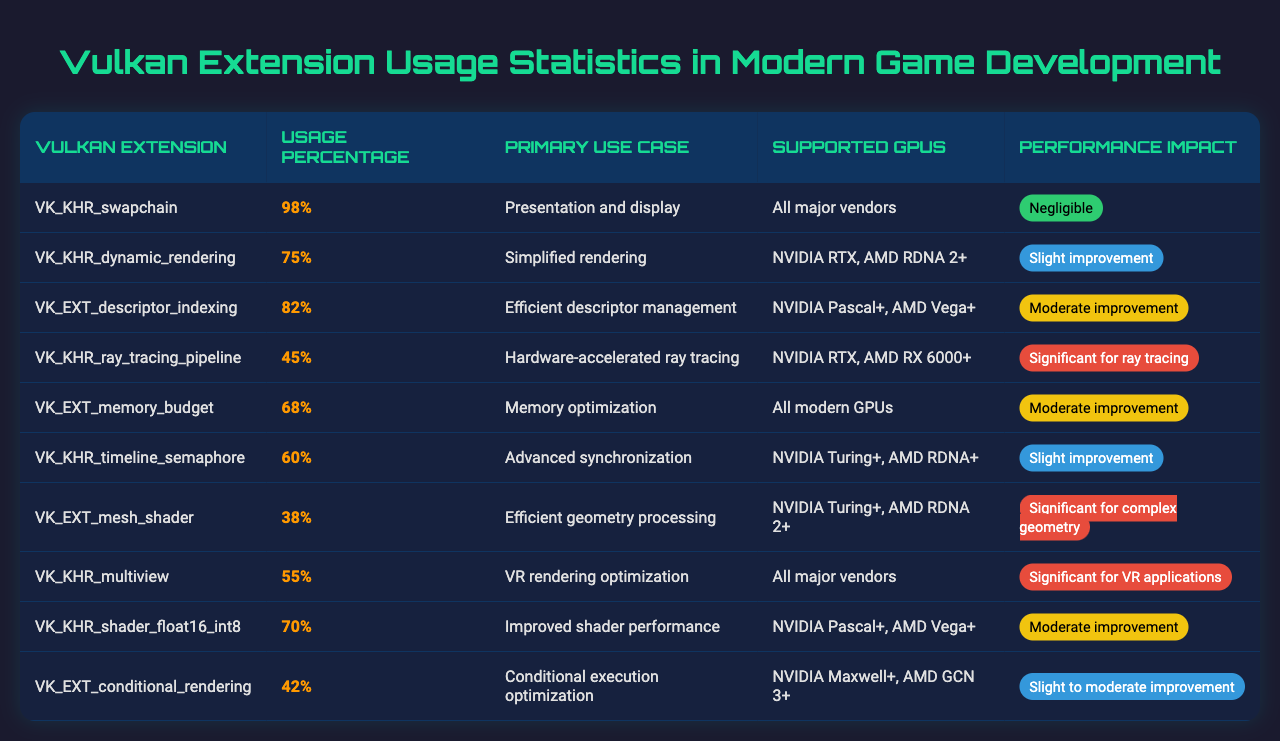What is the usage percentage of the VK_KHR_swapchain extension? The table shows that the usage percentage for the VK_KHR_swapchain extension is listed in the second column, which states 98%.
Answer: 98% Which Vulkan extension has the highest usage percentage, and what is its primary use case? The table indicates that the extension with the highest usage percentage is VK_KHR_swapchain at 98%, and its primary use case is "Presentation and display."
Answer: VK_KHR_swapchain; Presentation and display What percentage of developers use the VK_EXT_mesh_shader extension? The table shows the usage percentage for VK_EXT_mesh_shader in the second column, which states 38%.
Answer: 38% What is the primary use case for VK_KHR_ray_tracing_pipeline? The table indicates that the primary use case for VK_KHR_ray_tracing_pipeline is "Hardware-accelerated ray tracing."
Answer: Hardware-accelerated ray tracing Among the Vulkan extensions listed, which one has a performance impact classified as "Significant"? According to the table, VK_KHR_ray_tracing_pipeline and VK_KHR_multiview are classified as having a "Significant" performance impact.
Answer: VK_KHR_ray_tracing_pipeline and VK_KHR_multiview What is the average usage percentage of the extensions that offer a slight performance improvement? The extensions offering a slight improvement are VK_KHR_timeline_semaphore and VK_EXT_conditional_rendering, with usage percentages of 60% and 42% respectively. The average is calculated as (60 + 42) / 2 = 51.
Answer: 51% Is the VK_EXT_descriptor_indexing extension supported by all major GPU vendors? The table specifies that VK_EXT_descriptor_indexing is supported by NVIDIA Pascal+ and AMD Vega+, which does not include all major vendors.
Answer: No Which extension offers improved shader performance, and what is its usage percentage? The table states that VK_KHR_shader_float16_int8 offers improved shader performance with a usage percentage of 70%.
Answer: VK_KHR_shader_float16_int8; 70% How does the usage percentage of VK_EXT_memory_budget compare to that of VK_EXT_descriptor_indexing? The usage percentage for VK_EXT_memory_budget is 68% and for VK_EXT_descriptor_indexing is 82%. Since 82% is greater than 68%, VK_EXT_descriptor_indexing has a higher usage percentage.
Answer: VK_EXT_descriptor_indexing has a higher usage percentage What percentage of the extensions listed have their primary use case related to rendering optimization? The extensions related to rendering optimization are VK_EXT_memory_budget, VK_KHR_dynamic_rendering, and VK_KHR_multiview, with usage percentages of 68%, 75%, and 55% respectively, making a total of three relevant extensions out of ten. So, the percentage is (3 / 10) * 100 = 30%.
Answer: 30% 